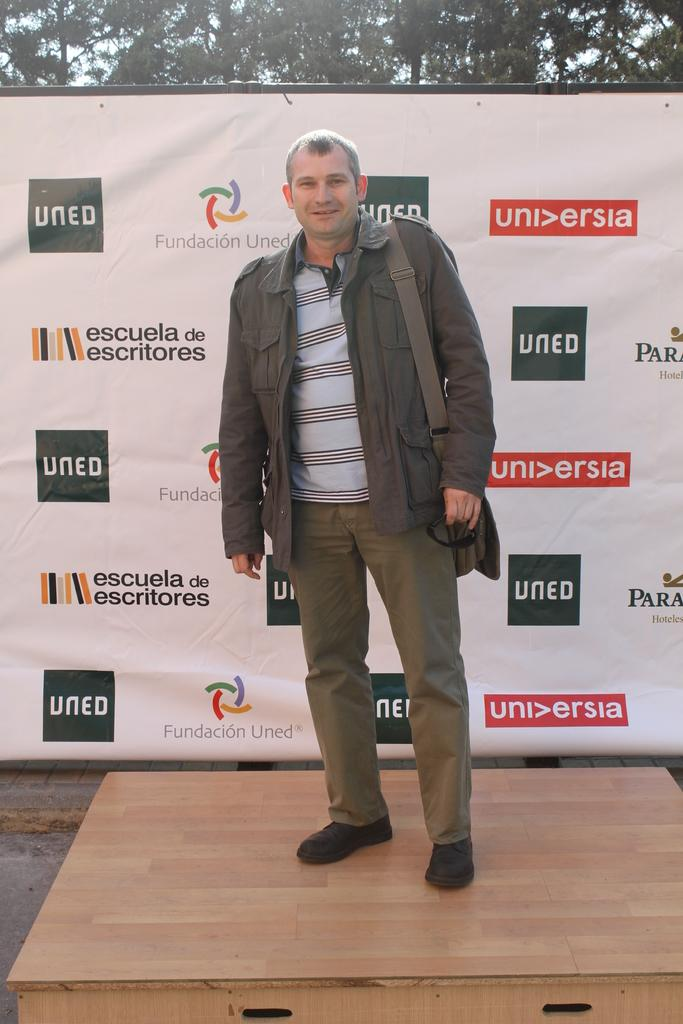What is the main subject of the image? The main subject of the image is a man. What is the man doing in the image? The man is standing in the image. What is the man's facial expression in the image? The man is smiling in the image. What else can be seen in the image besides the man? There is a banner and trees visible in the image. What type of sheet is being used by the man to assert his authority in the image? There is no sheet present in the image, and the man is not asserting any authority. What company is being represented by the man in the image? There is no indication of a company being represented in the image. 